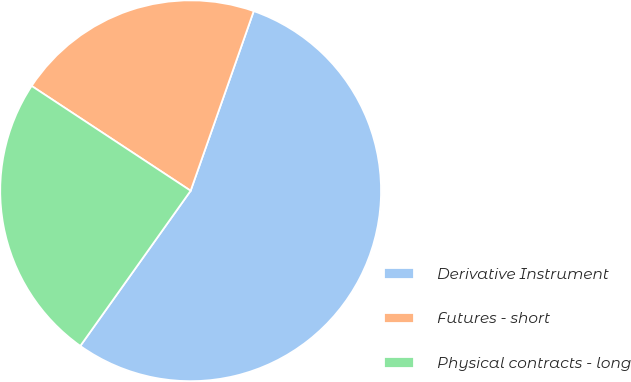<chart> <loc_0><loc_0><loc_500><loc_500><pie_chart><fcel>Derivative Instrument<fcel>Futures - short<fcel>Physical contracts - long<nl><fcel>54.46%<fcel>21.1%<fcel>24.44%<nl></chart> 